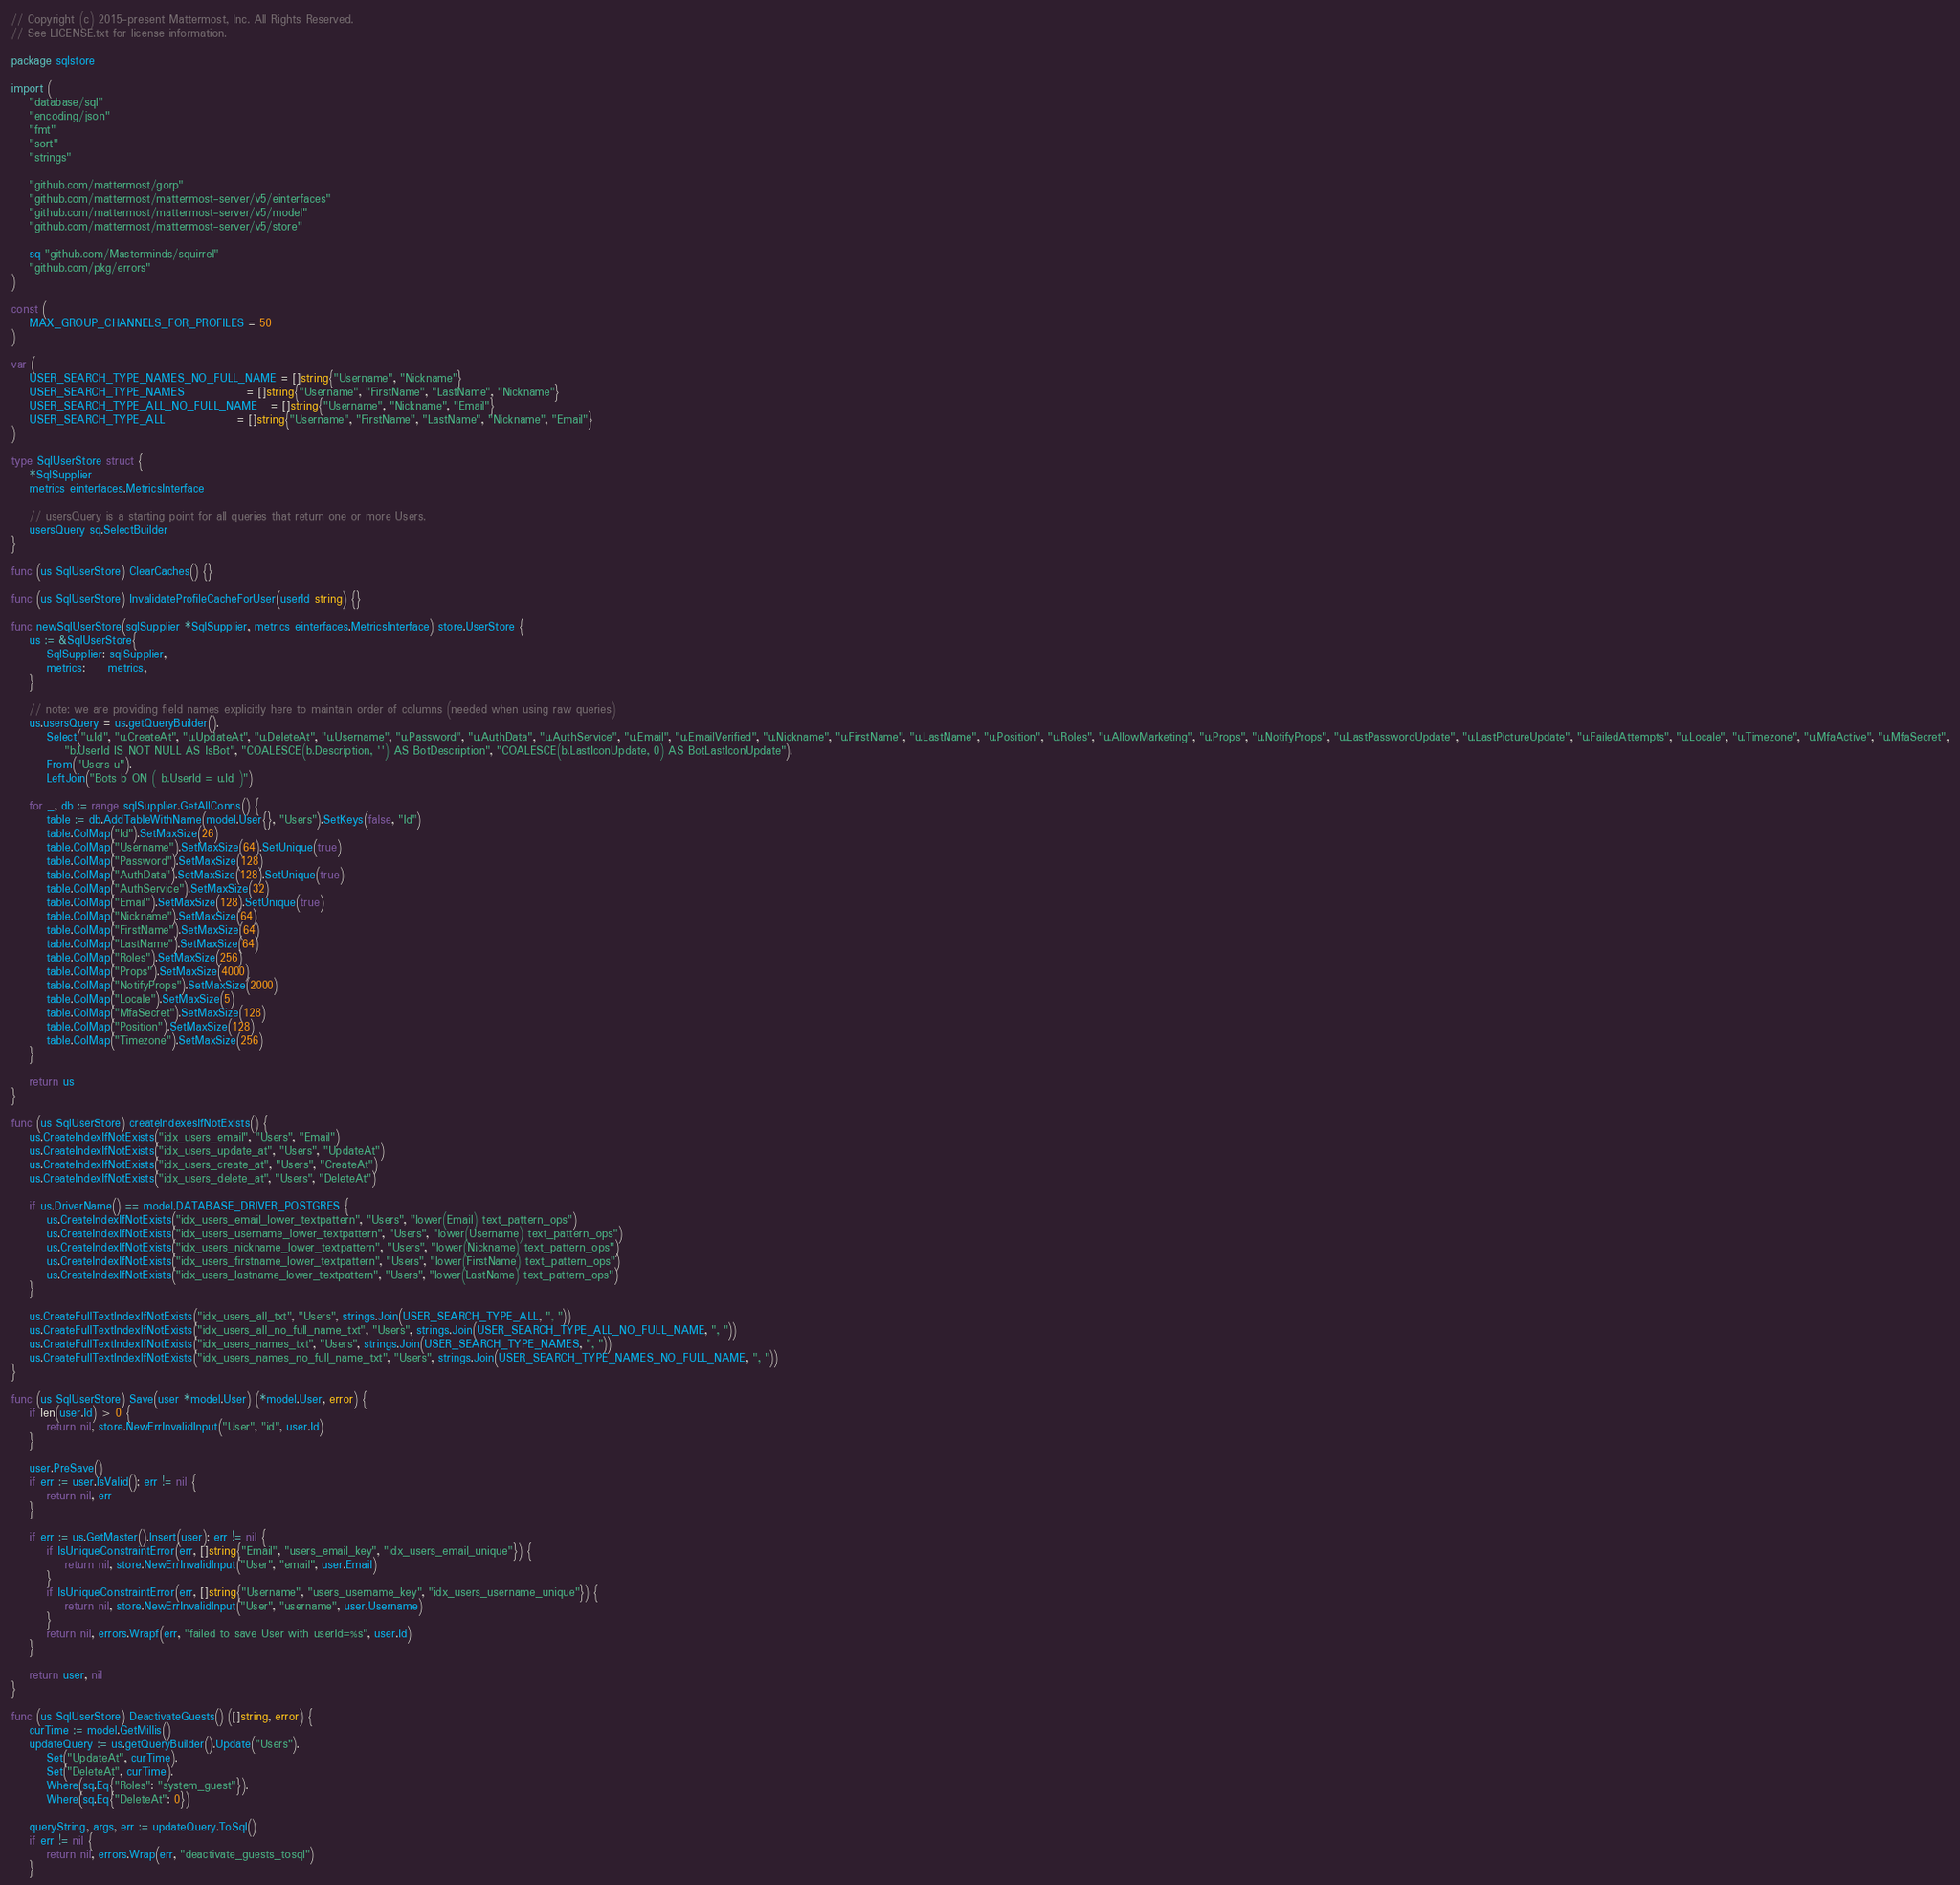<code> <loc_0><loc_0><loc_500><loc_500><_Go_>// Copyright (c) 2015-present Mattermost, Inc. All Rights Reserved.
// See LICENSE.txt for license information.

package sqlstore

import (
	"database/sql"
	"encoding/json"
	"fmt"
	"sort"
	"strings"

	"github.com/mattermost/gorp"
	"github.com/mattermost/mattermost-server/v5/einterfaces"
	"github.com/mattermost/mattermost-server/v5/model"
	"github.com/mattermost/mattermost-server/v5/store"

	sq "github.com/Masterminds/squirrel"
	"github.com/pkg/errors"
)

const (
	MAX_GROUP_CHANNELS_FOR_PROFILES = 50
)

var (
	USER_SEARCH_TYPE_NAMES_NO_FULL_NAME = []string{"Username", "Nickname"}
	USER_SEARCH_TYPE_NAMES              = []string{"Username", "FirstName", "LastName", "Nickname"}
	USER_SEARCH_TYPE_ALL_NO_FULL_NAME   = []string{"Username", "Nickname", "Email"}
	USER_SEARCH_TYPE_ALL                = []string{"Username", "FirstName", "LastName", "Nickname", "Email"}
)

type SqlUserStore struct {
	*SqlSupplier
	metrics einterfaces.MetricsInterface

	// usersQuery is a starting point for all queries that return one or more Users.
	usersQuery sq.SelectBuilder
}

func (us SqlUserStore) ClearCaches() {}

func (us SqlUserStore) InvalidateProfileCacheForUser(userId string) {}

func newSqlUserStore(sqlSupplier *SqlSupplier, metrics einterfaces.MetricsInterface) store.UserStore {
	us := &SqlUserStore{
		SqlSupplier: sqlSupplier,
		metrics:     metrics,
	}

	// note: we are providing field names explicitly here to maintain order of columns (needed when using raw queries)
	us.usersQuery = us.getQueryBuilder().
		Select("u.Id", "u.CreateAt", "u.UpdateAt", "u.DeleteAt", "u.Username", "u.Password", "u.AuthData", "u.AuthService", "u.Email", "u.EmailVerified", "u.Nickname", "u.FirstName", "u.LastName", "u.Position", "u.Roles", "u.AllowMarketing", "u.Props", "u.NotifyProps", "u.LastPasswordUpdate", "u.LastPictureUpdate", "u.FailedAttempts", "u.Locale", "u.Timezone", "u.MfaActive", "u.MfaSecret",
			"b.UserId IS NOT NULL AS IsBot", "COALESCE(b.Description, '') AS BotDescription", "COALESCE(b.LastIconUpdate, 0) AS BotLastIconUpdate").
		From("Users u").
		LeftJoin("Bots b ON ( b.UserId = u.Id )")

	for _, db := range sqlSupplier.GetAllConns() {
		table := db.AddTableWithName(model.User{}, "Users").SetKeys(false, "Id")
		table.ColMap("Id").SetMaxSize(26)
		table.ColMap("Username").SetMaxSize(64).SetUnique(true)
		table.ColMap("Password").SetMaxSize(128)
		table.ColMap("AuthData").SetMaxSize(128).SetUnique(true)
		table.ColMap("AuthService").SetMaxSize(32)
		table.ColMap("Email").SetMaxSize(128).SetUnique(true)
		table.ColMap("Nickname").SetMaxSize(64)
		table.ColMap("FirstName").SetMaxSize(64)
		table.ColMap("LastName").SetMaxSize(64)
		table.ColMap("Roles").SetMaxSize(256)
		table.ColMap("Props").SetMaxSize(4000)
		table.ColMap("NotifyProps").SetMaxSize(2000)
		table.ColMap("Locale").SetMaxSize(5)
		table.ColMap("MfaSecret").SetMaxSize(128)
		table.ColMap("Position").SetMaxSize(128)
		table.ColMap("Timezone").SetMaxSize(256)
	}

	return us
}

func (us SqlUserStore) createIndexesIfNotExists() {
	us.CreateIndexIfNotExists("idx_users_email", "Users", "Email")
	us.CreateIndexIfNotExists("idx_users_update_at", "Users", "UpdateAt")
	us.CreateIndexIfNotExists("idx_users_create_at", "Users", "CreateAt")
	us.CreateIndexIfNotExists("idx_users_delete_at", "Users", "DeleteAt")

	if us.DriverName() == model.DATABASE_DRIVER_POSTGRES {
		us.CreateIndexIfNotExists("idx_users_email_lower_textpattern", "Users", "lower(Email) text_pattern_ops")
		us.CreateIndexIfNotExists("idx_users_username_lower_textpattern", "Users", "lower(Username) text_pattern_ops")
		us.CreateIndexIfNotExists("idx_users_nickname_lower_textpattern", "Users", "lower(Nickname) text_pattern_ops")
		us.CreateIndexIfNotExists("idx_users_firstname_lower_textpattern", "Users", "lower(FirstName) text_pattern_ops")
		us.CreateIndexIfNotExists("idx_users_lastname_lower_textpattern", "Users", "lower(LastName) text_pattern_ops")
	}

	us.CreateFullTextIndexIfNotExists("idx_users_all_txt", "Users", strings.Join(USER_SEARCH_TYPE_ALL, ", "))
	us.CreateFullTextIndexIfNotExists("idx_users_all_no_full_name_txt", "Users", strings.Join(USER_SEARCH_TYPE_ALL_NO_FULL_NAME, ", "))
	us.CreateFullTextIndexIfNotExists("idx_users_names_txt", "Users", strings.Join(USER_SEARCH_TYPE_NAMES, ", "))
	us.CreateFullTextIndexIfNotExists("idx_users_names_no_full_name_txt", "Users", strings.Join(USER_SEARCH_TYPE_NAMES_NO_FULL_NAME, ", "))
}

func (us SqlUserStore) Save(user *model.User) (*model.User, error) {
	if len(user.Id) > 0 {
		return nil, store.NewErrInvalidInput("User", "id", user.Id)
	}

	user.PreSave()
	if err := user.IsValid(); err != nil {
		return nil, err
	}

	if err := us.GetMaster().Insert(user); err != nil {
		if IsUniqueConstraintError(err, []string{"Email", "users_email_key", "idx_users_email_unique"}) {
			return nil, store.NewErrInvalidInput("User", "email", user.Email)
		}
		if IsUniqueConstraintError(err, []string{"Username", "users_username_key", "idx_users_username_unique"}) {
			return nil, store.NewErrInvalidInput("User", "username", user.Username)
		}
		return nil, errors.Wrapf(err, "failed to save User with userId=%s", user.Id)
	}

	return user, nil
}

func (us SqlUserStore) DeactivateGuests() ([]string, error) {
	curTime := model.GetMillis()
	updateQuery := us.getQueryBuilder().Update("Users").
		Set("UpdateAt", curTime).
		Set("DeleteAt", curTime).
		Where(sq.Eq{"Roles": "system_guest"}).
		Where(sq.Eq{"DeleteAt": 0})

	queryString, args, err := updateQuery.ToSql()
	if err != nil {
		return nil, errors.Wrap(err, "deactivate_guests_tosql")
	}
</code> 